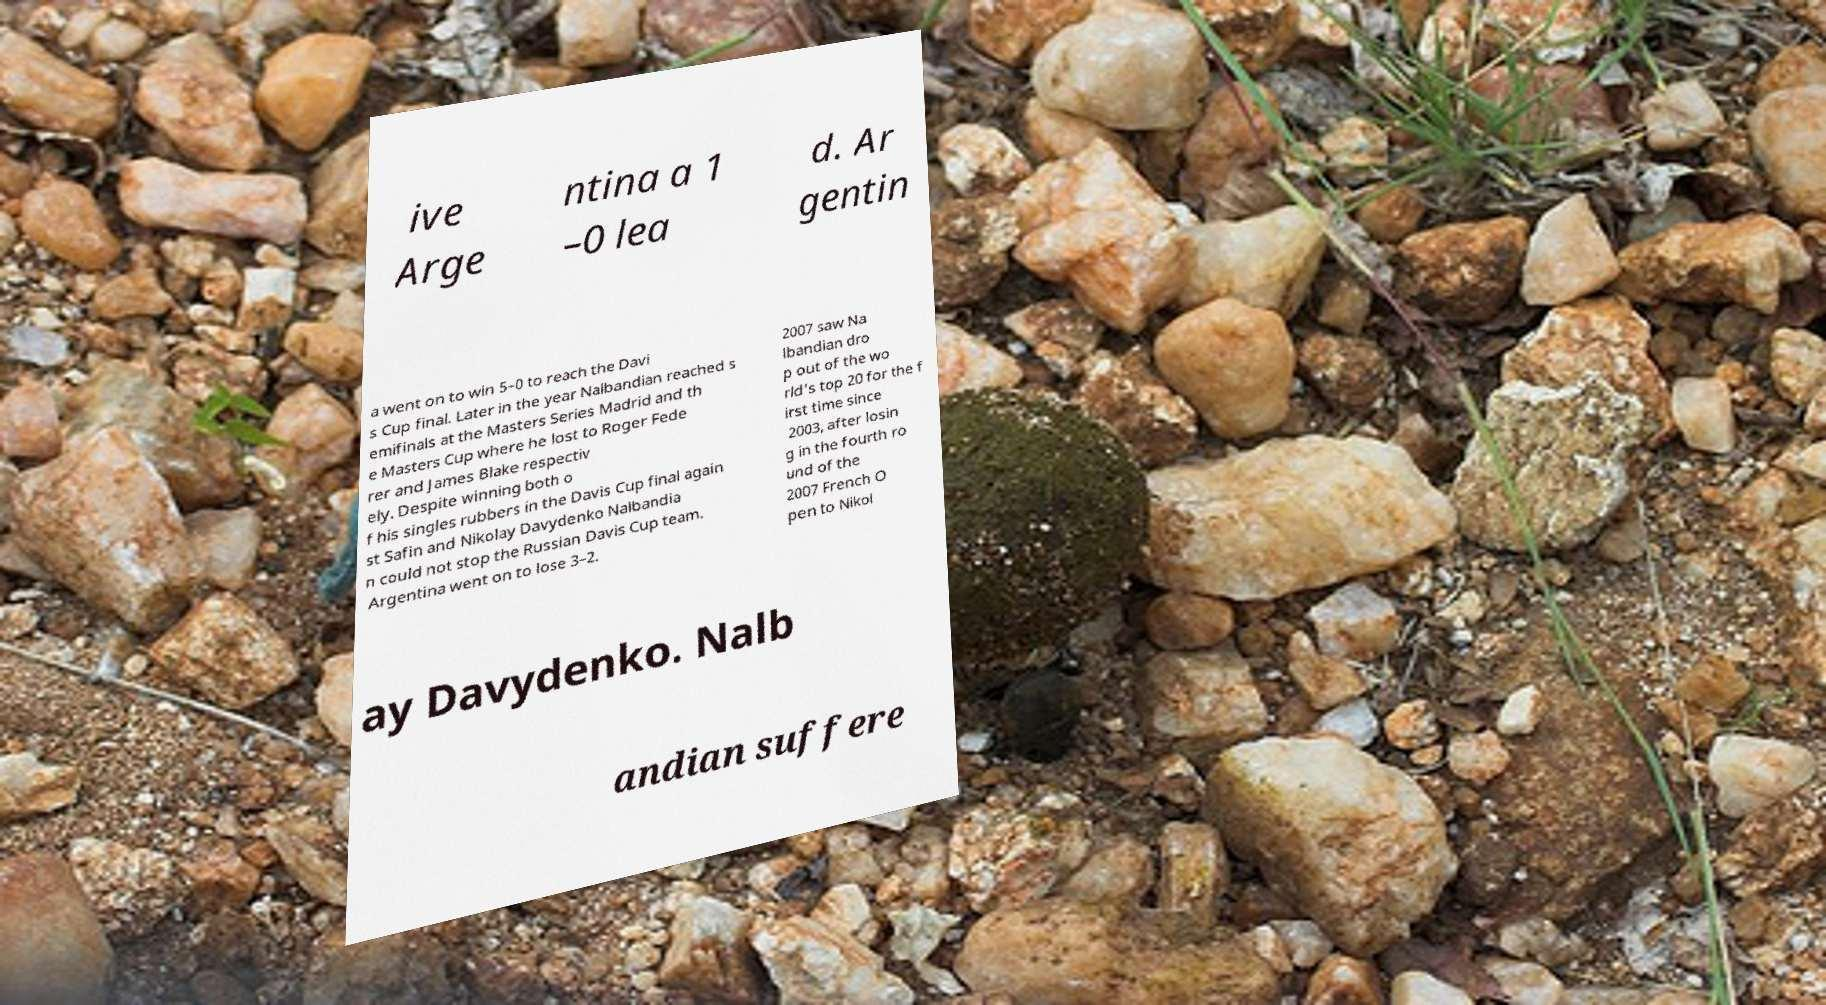Could you extract and type out the text from this image? ive Arge ntina a 1 –0 lea d. Ar gentin a went on to win 5–0 to reach the Davi s Cup final. Later in the year Nalbandian reached s emifinals at the Masters Series Madrid and th e Masters Cup where he lost to Roger Fede rer and James Blake respectiv ely. Despite winning both o f his singles rubbers in the Davis Cup final again st Safin and Nikolay Davydenko Nalbandia n could not stop the Russian Davis Cup team. Argentina went on to lose 3–2. 2007 saw Na lbandian dro p out of the wo rld's top 20 for the f irst time since 2003, after losin g in the fourth ro und of the 2007 French O pen to Nikol ay Davydenko. Nalb andian suffere 